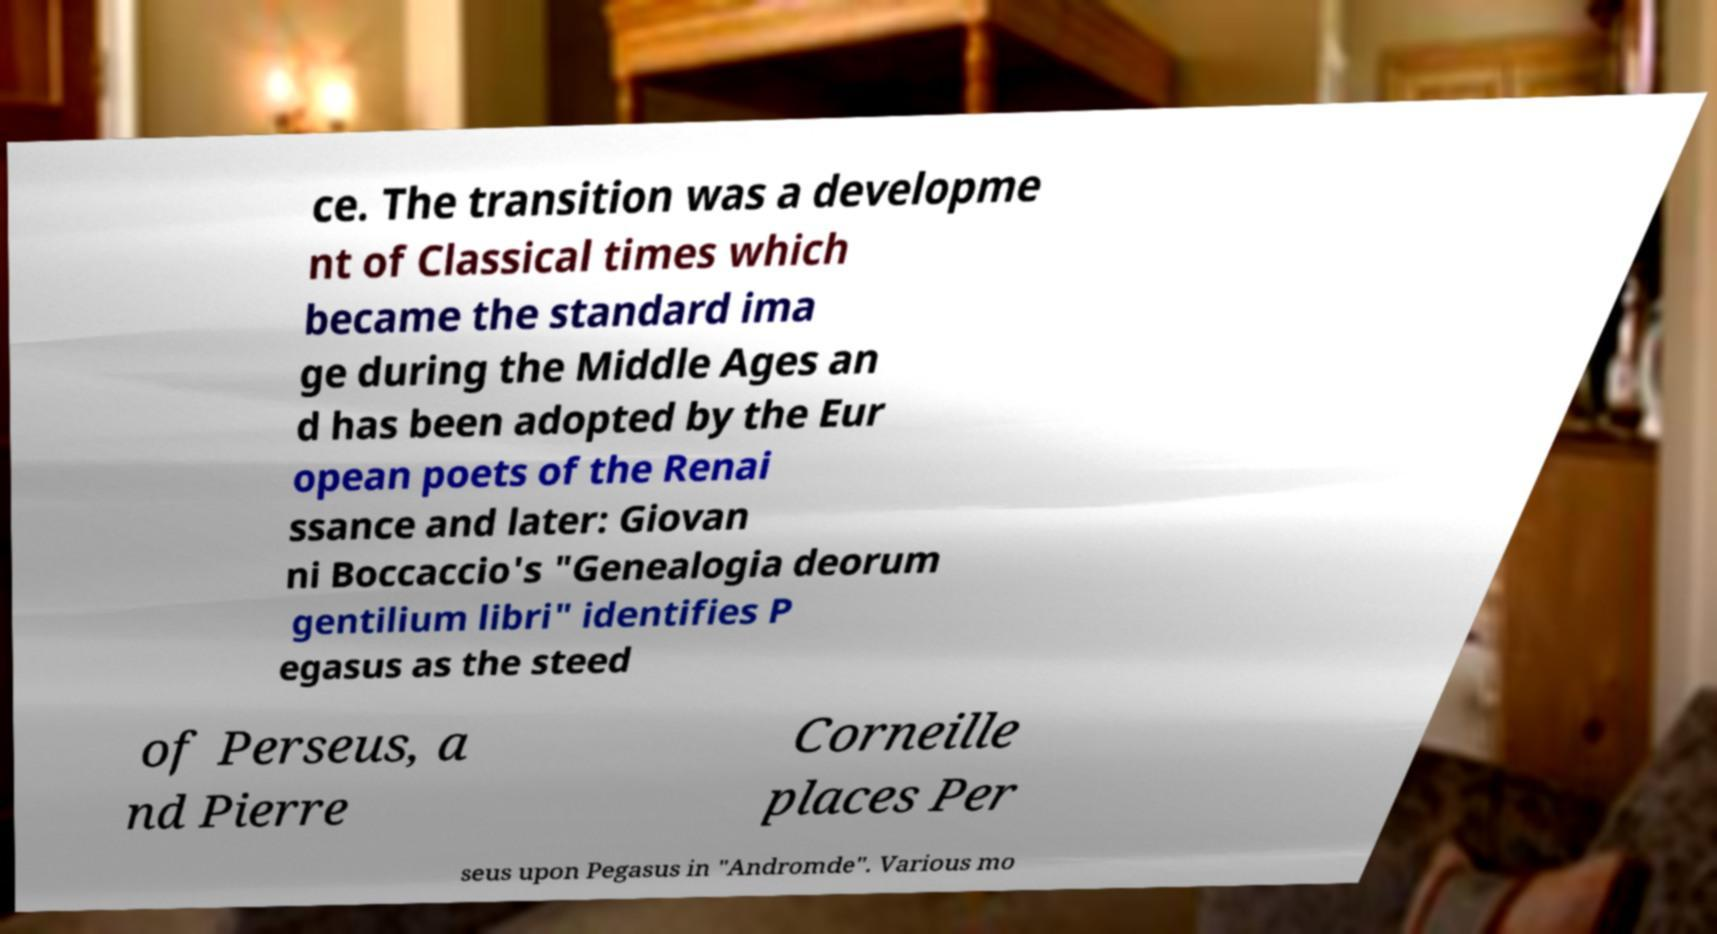There's text embedded in this image that I need extracted. Can you transcribe it verbatim? ce. The transition was a developme nt of Classical times which became the standard ima ge during the Middle Ages an d has been adopted by the Eur opean poets of the Renai ssance and later: Giovan ni Boccaccio's "Genealogia deorum gentilium libri" identifies P egasus as the steed of Perseus, a nd Pierre Corneille places Per seus upon Pegasus in "Andromde". Various mo 